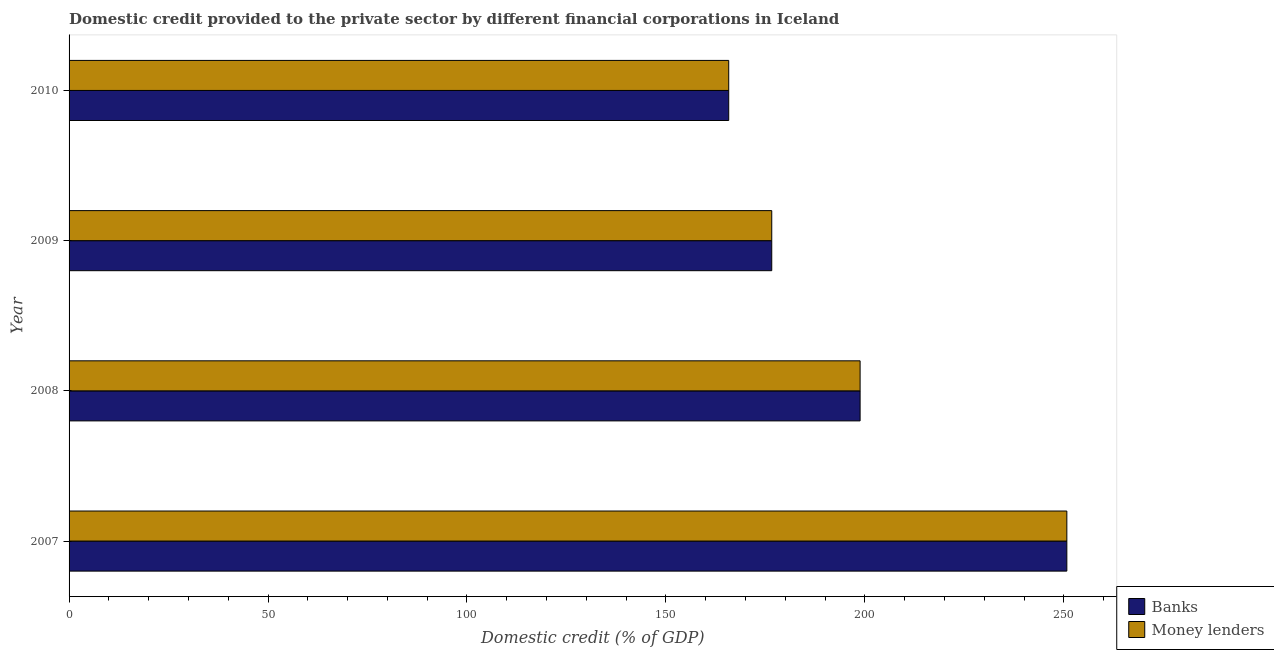How many groups of bars are there?
Ensure brevity in your answer.  4. Are the number of bars per tick equal to the number of legend labels?
Offer a very short reply. Yes. How many bars are there on the 2nd tick from the top?
Your answer should be very brief. 2. What is the domestic credit provided by money lenders in 2010?
Your answer should be very brief. 165.78. Across all years, what is the maximum domestic credit provided by banks?
Give a very brief answer. 250.76. Across all years, what is the minimum domestic credit provided by banks?
Provide a short and direct response. 165.78. What is the total domestic credit provided by banks in the graph?
Keep it short and to the point. 791.96. What is the difference between the domestic credit provided by money lenders in 2008 and that in 2010?
Give a very brief answer. 33.02. What is the difference between the domestic credit provided by money lenders in 2009 and the domestic credit provided by banks in 2008?
Your answer should be compact. -22.2. What is the average domestic credit provided by banks per year?
Provide a short and direct response. 197.99. In how many years, is the domestic credit provided by banks greater than 150 %?
Keep it short and to the point. 4. What is the ratio of the domestic credit provided by money lenders in 2009 to that in 2010?
Provide a succinct answer. 1.06. Is the domestic credit provided by money lenders in 2008 less than that in 2009?
Give a very brief answer. No. What is the difference between the highest and the second highest domestic credit provided by money lenders?
Keep it short and to the point. 51.96. What is the difference between the highest and the lowest domestic credit provided by banks?
Your answer should be compact. 84.98. Is the sum of the domestic credit provided by banks in 2007 and 2008 greater than the maximum domestic credit provided by money lenders across all years?
Offer a very short reply. Yes. What does the 2nd bar from the top in 2008 represents?
Offer a very short reply. Banks. What does the 1st bar from the bottom in 2009 represents?
Your answer should be very brief. Banks. Are all the bars in the graph horizontal?
Offer a very short reply. Yes. What is the difference between two consecutive major ticks on the X-axis?
Make the answer very short. 50. How many legend labels are there?
Offer a very short reply. 2. What is the title of the graph?
Provide a succinct answer. Domestic credit provided to the private sector by different financial corporations in Iceland. Does "US$" appear as one of the legend labels in the graph?
Make the answer very short. No. What is the label or title of the X-axis?
Offer a very short reply. Domestic credit (% of GDP). What is the label or title of the Y-axis?
Offer a terse response. Year. What is the Domestic credit (% of GDP) of Banks in 2007?
Offer a terse response. 250.76. What is the Domestic credit (% of GDP) of Money lenders in 2007?
Your answer should be very brief. 250.76. What is the Domestic credit (% of GDP) of Banks in 2008?
Give a very brief answer. 198.81. What is the Domestic credit (% of GDP) of Money lenders in 2008?
Keep it short and to the point. 198.81. What is the Domestic credit (% of GDP) of Banks in 2009?
Ensure brevity in your answer.  176.6. What is the Domestic credit (% of GDP) in Money lenders in 2009?
Your answer should be compact. 176.6. What is the Domestic credit (% of GDP) of Banks in 2010?
Your answer should be very brief. 165.78. What is the Domestic credit (% of GDP) in Money lenders in 2010?
Offer a very short reply. 165.78. Across all years, what is the maximum Domestic credit (% of GDP) in Banks?
Provide a short and direct response. 250.76. Across all years, what is the maximum Domestic credit (% of GDP) in Money lenders?
Make the answer very short. 250.76. Across all years, what is the minimum Domestic credit (% of GDP) in Banks?
Provide a succinct answer. 165.78. Across all years, what is the minimum Domestic credit (% of GDP) in Money lenders?
Offer a terse response. 165.78. What is the total Domestic credit (% of GDP) of Banks in the graph?
Your answer should be compact. 791.96. What is the total Domestic credit (% of GDP) of Money lenders in the graph?
Your answer should be very brief. 791.96. What is the difference between the Domestic credit (% of GDP) of Banks in 2007 and that in 2008?
Keep it short and to the point. 51.96. What is the difference between the Domestic credit (% of GDP) in Money lenders in 2007 and that in 2008?
Provide a short and direct response. 51.96. What is the difference between the Domestic credit (% of GDP) in Banks in 2007 and that in 2009?
Keep it short and to the point. 74.16. What is the difference between the Domestic credit (% of GDP) of Money lenders in 2007 and that in 2009?
Your response must be concise. 74.16. What is the difference between the Domestic credit (% of GDP) of Banks in 2007 and that in 2010?
Provide a short and direct response. 84.98. What is the difference between the Domestic credit (% of GDP) of Money lenders in 2007 and that in 2010?
Provide a succinct answer. 84.98. What is the difference between the Domestic credit (% of GDP) of Banks in 2008 and that in 2009?
Give a very brief answer. 22.2. What is the difference between the Domestic credit (% of GDP) of Money lenders in 2008 and that in 2009?
Your answer should be compact. 22.2. What is the difference between the Domestic credit (% of GDP) in Banks in 2008 and that in 2010?
Make the answer very short. 33.02. What is the difference between the Domestic credit (% of GDP) of Money lenders in 2008 and that in 2010?
Keep it short and to the point. 33.02. What is the difference between the Domestic credit (% of GDP) in Banks in 2009 and that in 2010?
Your response must be concise. 10.82. What is the difference between the Domestic credit (% of GDP) of Money lenders in 2009 and that in 2010?
Your response must be concise. 10.82. What is the difference between the Domestic credit (% of GDP) of Banks in 2007 and the Domestic credit (% of GDP) of Money lenders in 2008?
Provide a succinct answer. 51.96. What is the difference between the Domestic credit (% of GDP) of Banks in 2007 and the Domestic credit (% of GDP) of Money lenders in 2009?
Keep it short and to the point. 74.16. What is the difference between the Domestic credit (% of GDP) in Banks in 2007 and the Domestic credit (% of GDP) in Money lenders in 2010?
Offer a very short reply. 84.98. What is the difference between the Domestic credit (% of GDP) in Banks in 2008 and the Domestic credit (% of GDP) in Money lenders in 2009?
Keep it short and to the point. 22.2. What is the difference between the Domestic credit (% of GDP) in Banks in 2008 and the Domestic credit (% of GDP) in Money lenders in 2010?
Give a very brief answer. 33.02. What is the difference between the Domestic credit (% of GDP) in Banks in 2009 and the Domestic credit (% of GDP) in Money lenders in 2010?
Ensure brevity in your answer.  10.82. What is the average Domestic credit (% of GDP) in Banks per year?
Keep it short and to the point. 197.99. What is the average Domestic credit (% of GDP) of Money lenders per year?
Ensure brevity in your answer.  197.99. In the year 2008, what is the difference between the Domestic credit (% of GDP) in Banks and Domestic credit (% of GDP) in Money lenders?
Offer a terse response. 0. In the year 2009, what is the difference between the Domestic credit (% of GDP) in Banks and Domestic credit (% of GDP) in Money lenders?
Your answer should be compact. 0. What is the ratio of the Domestic credit (% of GDP) in Banks in 2007 to that in 2008?
Give a very brief answer. 1.26. What is the ratio of the Domestic credit (% of GDP) of Money lenders in 2007 to that in 2008?
Your answer should be very brief. 1.26. What is the ratio of the Domestic credit (% of GDP) of Banks in 2007 to that in 2009?
Provide a short and direct response. 1.42. What is the ratio of the Domestic credit (% of GDP) in Money lenders in 2007 to that in 2009?
Make the answer very short. 1.42. What is the ratio of the Domestic credit (% of GDP) in Banks in 2007 to that in 2010?
Provide a succinct answer. 1.51. What is the ratio of the Domestic credit (% of GDP) of Money lenders in 2007 to that in 2010?
Provide a short and direct response. 1.51. What is the ratio of the Domestic credit (% of GDP) of Banks in 2008 to that in 2009?
Your answer should be very brief. 1.13. What is the ratio of the Domestic credit (% of GDP) of Money lenders in 2008 to that in 2009?
Make the answer very short. 1.13. What is the ratio of the Domestic credit (% of GDP) in Banks in 2008 to that in 2010?
Make the answer very short. 1.2. What is the ratio of the Domestic credit (% of GDP) in Money lenders in 2008 to that in 2010?
Provide a short and direct response. 1.2. What is the ratio of the Domestic credit (% of GDP) of Banks in 2009 to that in 2010?
Ensure brevity in your answer.  1.07. What is the ratio of the Domestic credit (% of GDP) in Money lenders in 2009 to that in 2010?
Offer a terse response. 1.07. What is the difference between the highest and the second highest Domestic credit (% of GDP) of Banks?
Ensure brevity in your answer.  51.96. What is the difference between the highest and the second highest Domestic credit (% of GDP) of Money lenders?
Provide a succinct answer. 51.96. What is the difference between the highest and the lowest Domestic credit (% of GDP) of Banks?
Your answer should be very brief. 84.98. What is the difference between the highest and the lowest Domestic credit (% of GDP) of Money lenders?
Provide a succinct answer. 84.98. 